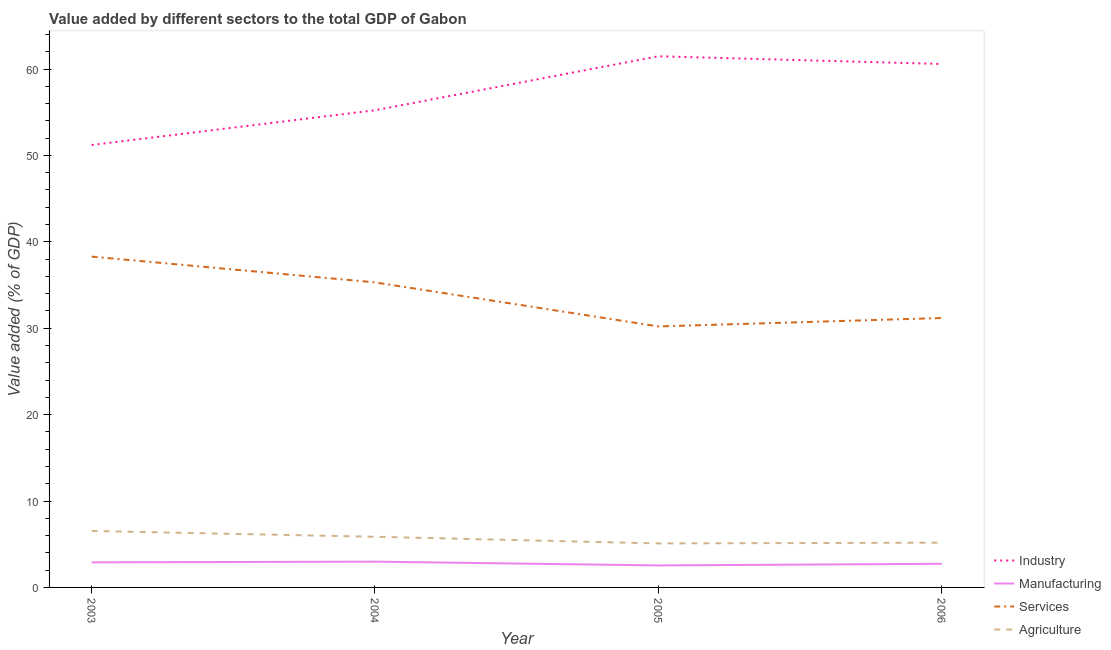How many different coloured lines are there?
Your answer should be very brief. 4. What is the value added by manufacturing sector in 2005?
Your answer should be very brief. 2.55. Across all years, what is the maximum value added by manufacturing sector?
Provide a short and direct response. 2.98. Across all years, what is the minimum value added by manufacturing sector?
Offer a very short reply. 2.55. In which year was the value added by services sector minimum?
Offer a terse response. 2005. What is the total value added by services sector in the graph?
Your answer should be compact. 134.99. What is the difference between the value added by agricultural sector in 2003 and that in 2004?
Offer a terse response. 0.67. What is the difference between the value added by industrial sector in 2004 and the value added by agricultural sector in 2005?
Your answer should be very brief. 50.13. What is the average value added by industrial sector per year?
Your response must be concise. 57.12. In the year 2004, what is the difference between the value added by services sector and value added by industrial sector?
Your answer should be compact. -19.92. In how many years, is the value added by agricultural sector greater than 2 %?
Keep it short and to the point. 4. What is the ratio of the value added by agricultural sector in 2003 to that in 2006?
Your answer should be very brief. 1.26. What is the difference between the highest and the second highest value added by agricultural sector?
Your answer should be compact. 0.67. What is the difference between the highest and the lowest value added by agricultural sector?
Provide a short and direct response. 1.44. Is the sum of the value added by agricultural sector in 2004 and 2005 greater than the maximum value added by industrial sector across all years?
Keep it short and to the point. No. Is it the case that in every year, the sum of the value added by industrial sector and value added by agricultural sector is greater than the sum of value added by manufacturing sector and value added by services sector?
Offer a very short reply. Yes. Does the value added by services sector monotonically increase over the years?
Provide a succinct answer. No. How many lines are there?
Ensure brevity in your answer.  4. Does the graph contain any zero values?
Your answer should be compact. No. Does the graph contain grids?
Your response must be concise. No. Where does the legend appear in the graph?
Keep it short and to the point. Bottom right. How are the legend labels stacked?
Provide a short and direct response. Vertical. What is the title of the graph?
Keep it short and to the point. Value added by different sectors to the total GDP of Gabon. Does "Secondary general education" appear as one of the legend labels in the graph?
Offer a terse response. No. What is the label or title of the X-axis?
Ensure brevity in your answer.  Year. What is the label or title of the Y-axis?
Your response must be concise. Value added (% of GDP). What is the Value added (% of GDP) in Industry in 2003?
Provide a short and direct response. 51.21. What is the Value added (% of GDP) in Manufacturing in 2003?
Provide a short and direct response. 2.9. What is the Value added (% of GDP) of Services in 2003?
Offer a very short reply. 38.29. What is the Value added (% of GDP) of Agriculture in 2003?
Keep it short and to the point. 6.54. What is the Value added (% of GDP) in Industry in 2004?
Provide a short and direct response. 55.23. What is the Value added (% of GDP) of Manufacturing in 2004?
Offer a terse response. 2.98. What is the Value added (% of GDP) in Services in 2004?
Give a very brief answer. 35.3. What is the Value added (% of GDP) of Agriculture in 2004?
Provide a short and direct response. 5.86. What is the Value added (% of GDP) in Industry in 2005?
Offer a very short reply. 61.47. What is the Value added (% of GDP) in Manufacturing in 2005?
Ensure brevity in your answer.  2.55. What is the Value added (% of GDP) of Services in 2005?
Your answer should be very brief. 30.21. What is the Value added (% of GDP) of Agriculture in 2005?
Keep it short and to the point. 5.09. What is the Value added (% of GDP) in Industry in 2006?
Offer a terse response. 60.58. What is the Value added (% of GDP) in Manufacturing in 2006?
Offer a very short reply. 2.74. What is the Value added (% of GDP) of Services in 2006?
Your answer should be compact. 31.18. What is the Value added (% of GDP) in Agriculture in 2006?
Make the answer very short. 5.18. Across all years, what is the maximum Value added (% of GDP) of Industry?
Your answer should be very brief. 61.47. Across all years, what is the maximum Value added (% of GDP) of Manufacturing?
Provide a succinct answer. 2.98. Across all years, what is the maximum Value added (% of GDP) in Services?
Provide a short and direct response. 38.29. Across all years, what is the maximum Value added (% of GDP) in Agriculture?
Make the answer very short. 6.54. Across all years, what is the minimum Value added (% of GDP) in Industry?
Offer a terse response. 51.21. Across all years, what is the minimum Value added (% of GDP) of Manufacturing?
Your answer should be compact. 2.55. Across all years, what is the minimum Value added (% of GDP) of Services?
Keep it short and to the point. 30.21. Across all years, what is the minimum Value added (% of GDP) of Agriculture?
Keep it short and to the point. 5.09. What is the total Value added (% of GDP) of Industry in the graph?
Keep it short and to the point. 228.49. What is the total Value added (% of GDP) in Manufacturing in the graph?
Offer a terse response. 11.17. What is the total Value added (% of GDP) in Services in the graph?
Offer a very short reply. 134.99. What is the total Value added (% of GDP) in Agriculture in the graph?
Provide a short and direct response. 22.67. What is the difference between the Value added (% of GDP) of Industry in 2003 and that in 2004?
Keep it short and to the point. -4.02. What is the difference between the Value added (% of GDP) of Manufacturing in 2003 and that in 2004?
Provide a succinct answer. -0.08. What is the difference between the Value added (% of GDP) of Services in 2003 and that in 2004?
Your answer should be very brief. 2.99. What is the difference between the Value added (% of GDP) of Agriculture in 2003 and that in 2004?
Your answer should be compact. 0.67. What is the difference between the Value added (% of GDP) in Industry in 2003 and that in 2005?
Ensure brevity in your answer.  -10.27. What is the difference between the Value added (% of GDP) in Manufacturing in 2003 and that in 2005?
Your answer should be very brief. 0.36. What is the difference between the Value added (% of GDP) of Services in 2003 and that in 2005?
Your answer should be compact. 8.08. What is the difference between the Value added (% of GDP) in Agriculture in 2003 and that in 2005?
Provide a short and direct response. 1.44. What is the difference between the Value added (% of GDP) of Industry in 2003 and that in 2006?
Provide a succinct answer. -9.37. What is the difference between the Value added (% of GDP) in Manufacturing in 2003 and that in 2006?
Keep it short and to the point. 0.17. What is the difference between the Value added (% of GDP) in Services in 2003 and that in 2006?
Give a very brief answer. 7.11. What is the difference between the Value added (% of GDP) in Agriculture in 2003 and that in 2006?
Ensure brevity in your answer.  1.36. What is the difference between the Value added (% of GDP) in Industry in 2004 and that in 2005?
Your response must be concise. -6.25. What is the difference between the Value added (% of GDP) in Manufacturing in 2004 and that in 2005?
Keep it short and to the point. 0.44. What is the difference between the Value added (% of GDP) in Services in 2004 and that in 2005?
Ensure brevity in your answer.  5.1. What is the difference between the Value added (% of GDP) of Agriculture in 2004 and that in 2005?
Give a very brief answer. 0.77. What is the difference between the Value added (% of GDP) in Industry in 2004 and that in 2006?
Your answer should be compact. -5.36. What is the difference between the Value added (% of GDP) of Manufacturing in 2004 and that in 2006?
Ensure brevity in your answer.  0.25. What is the difference between the Value added (% of GDP) in Services in 2004 and that in 2006?
Provide a succinct answer. 4.12. What is the difference between the Value added (% of GDP) of Agriculture in 2004 and that in 2006?
Your response must be concise. 0.68. What is the difference between the Value added (% of GDP) in Industry in 2005 and that in 2006?
Your answer should be very brief. 0.89. What is the difference between the Value added (% of GDP) in Manufacturing in 2005 and that in 2006?
Keep it short and to the point. -0.19. What is the difference between the Value added (% of GDP) in Services in 2005 and that in 2006?
Give a very brief answer. -0.97. What is the difference between the Value added (% of GDP) in Agriculture in 2005 and that in 2006?
Offer a terse response. -0.08. What is the difference between the Value added (% of GDP) of Industry in 2003 and the Value added (% of GDP) of Manufacturing in 2004?
Your answer should be very brief. 48.22. What is the difference between the Value added (% of GDP) of Industry in 2003 and the Value added (% of GDP) of Services in 2004?
Provide a succinct answer. 15.9. What is the difference between the Value added (% of GDP) of Industry in 2003 and the Value added (% of GDP) of Agriculture in 2004?
Your response must be concise. 45.34. What is the difference between the Value added (% of GDP) of Manufacturing in 2003 and the Value added (% of GDP) of Services in 2004?
Provide a short and direct response. -32.4. What is the difference between the Value added (% of GDP) of Manufacturing in 2003 and the Value added (% of GDP) of Agriculture in 2004?
Offer a terse response. -2.96. What is the difference between the Value added (% of GDP) of Services in 2003 and the Value added (% of GDP) of Agriculture in 2004?
Ensure brevity in your answer.  32.43. What is the difference between the Value added (% of GDP) of Industry in 2003 and the Value added (% of GDP) of Manufacturing in 2005?
Offer a terse response. 48.66. What is the difference between the Value added (% of GDP) of Industry in 2003 and the Value added (% of GDP) of Services in 2005?
Your response must be concise. 21. What is the difference between the Value added (% of GDP) in Industry in 2003 and the Value added (% of GDP) in Agriculture in 2005?
Give a very brief answer. 46.11. What is the difference between the Value added (% of GDP) of Manufacturing in 2003 and the Value added (% of GDP) of Services in 2005?
Your answer should be very brief. -27.3. What is the difference between the Value added (% of GDP) of Manufacturing in 2003 and the Value added (% of GDP) of Agriculture in 2005?
Offer a very short reply. -2.19. What is the difference between the Value added (% of GDP) of Services in 2003 and the Value added (% of GDP) of Agriculture in 2005?
Your response must be concise. 33.2. What is the difference between the Value added (% of GDP) in Industry in 2003 and the Value added (% of GDP) in Manufacturing in 2006?
Provide a short and direct response. 48.47. What is the difference between the Value added (% of GDP) in Industry in 2003 and the Value added (% of GDP) in Services in 2006?
Give a very brief answer. 20.03. What is the difference between the Value added (% of GDP) of Industry in 2003 and the Value added (% of GDP) of Agriculture in 2006?
Offer a very short reply. 46.03. What is the difference between the Value added (% of GDP) in Manufacturing in 2003 and the Value added (% of GDP) in Services in 2006?
Provide a short and direct response. -28.28. What is the difference between the Value added (% of GDP) of Manufacturing in 2003 and the Value added (% of GDP) of Agriculture in 2006?
Your answer should be compact. -2.28. What is the difference between the Value added (% of GDP) of Services in 2003 and the Value added (% of GDP) of Agriculture in 2006?
Your response must be concise. 33.11. What is the difference between the Value added (% of GDP) of Industry in 2004 and the Value added (% of GDP) of Manufacturing in 2005?
Keep it short and to the point. 52.68. What is the difference between the Value added (% of GDP) of Industry in 2004 and the Value added (% of GDP) of Services in 2005?
Offer a very short reply. 25.02. What is the difference between the Value added (% of GDP) in Industry in 2004 and the Value added (% of GDP) in Agriculture in 2005?
Provide a succinct answer. 50.13. What is the difference between the Value added (% of GDP) in Manufacturing in 2004 and the Value added (% of GDP) in Services in 2005?
Keep it short and to the point. -27.23. What is the difference between the Value added (% of GDP) in Manufacturing in 2004 and the Value added (% of GDP) in Agriculture in 2005?
Make the answer very short. -2.11. What is the difference between the Value added (% of GDP) in Services in 2004 and the Value added (% of GDP) in Agriculture in 2005?
Your answer should be compact. 30.21. What is the difference between the Value added (% of GDP) of Industry in 2004 and the Value added (% of GDP) of Manufacturing in 2006?
Your response must be concise. 52.49. What is the difference between the Value added (% of GDP) of Industry in 2004 and the Value added (% of GDP) of Services in 2006?
Give a very brief answer. 24.04. What is the difference between the Value added (% of GDP) in Industry in 2004 and the Value added (% of GDP) in Agriculture in 2006?
Your response must be concise. 50.05. What is the difference between the Value added (% of GDP) of Manufacturing in 2004 and the Value added (% of GDP) of Services in 2006?
Ensure brevity in your answer.  -28.2. What is the difference between the Value added (% of GDP) of Manufacturing in 2004 and the Value added (% of GDP) of Agriculture in 2006?
Give a very brief answer. -2.2. What is the difference between the Value added (% of GDP) of Services in 2004 and the Value added (% of GDP) of Agriculture in 2006?
Provide a succinct answer. 30.13. What is the difference between the Value added (% of GDP) of Industry in 2005 and the Value added (% of GDP) of Manufacturing in 2006?
Offer a very short reply. 58.74. What is the difference between the Value added (% of GDP) of Industry in 2005 and the Value added (% of GDP) of Services in 2006?
Ensure brevity in your answer.  30.29. What is the difference between the Value added (% of GDP) in Industry in 2005 and the Value added (% of GDP) in Agriculture in 2006?
Provide a short and direct response. 56.29. What is the difference between the Value added (% of GDP) of Manufacturing in 2005 and the Value added (% of GDP) of Services in 2006?
Provide a succinct answer. -28.63. What is the difference between the Value added (% of GDP) of Manufacturing in 2005 and the Value added (% of GDP) of Agriculture in 2006?
Provide a short and direct response. -2.63. What is the difference between the Value added (% of GDP) in Services in 2005 and the Value added (% of GDP) in Agriculture in 2006?
Make the answer very short. 25.03. What is the average Value added (% of GDP) in Industry per year?
Keep it short and to the point. 57.12. What is the average Value added (% of GDP) of Manufacturing per year?
Ensure brevity in your answer.  2.79. What is the average Value added (% of GDP) in Services per year?
Provide a short and direct response. 33.75. What is the average Value added (% of GDP) of Agriculture per year?
Give a very brief answer. 5.67. In the year 2003, what is the difference between the Value added (% of GDP) of Industry and Value added (% of GDP) of Manufacturing?
Keep it short and to the point. 48.3. In the year 2003, what is the difference between the Value added (% of GDP) of Industry and Value added (% of GDP) of Services?
Your response must be concise. 12.92. In the year 2003, what is the difference between the Value added (% of GDP) in Industry and Value added (% of GDP) in Agriculture?
Provide a short and direct response. 44.67. In the year 2003, what is the difference between the Value added (% of GDP) in Manufacturing and Value added (% of GDP) in Services?
Give a very brief answer. -35.39. In the year 2003, what is the difference between the Value added (% of GDP) of Manufacturing and Value added (% of GDP) of Agriculture?
Keep it short and to the point. -3.63. In the year 2003, what is the difference between the Value added (% of GDP) in Services and Value added (% of GDP) in Agriculture?
Ensure brevity in your answer.  31.75. In the year 2004, what is the difference between the Value added (% of GDP) of Industry and Value added (% of GDP) of Manufacturing?
Your answer should be compact. 52.24. In the year 2004, what is the difference between the Value added (% of GDP) of Industry and Value added (% of GDP) of Services?
Your answer should be very brief. 19.92. In the year 2004, what is the difference between the Value added (% of GDP) in Industry and Value added (% of GDP) in Agriculture?
Keep it short and to the point. 49.36. In the year 2004, what is the difference between the Value added (% of GDP) in Manufacturing and Value added (% of GDP) in Services?
Provide a succinct answer. -32.32. In the year 2004, what is the difference between the Value added (% of GDP) of Manufacturing and Value added (% of GDP) of Agriculture?
Your answer should be compact. -2.88. In the year 2004, what is the difference between the Value added (% of GDP) of Services and Value added (% of GDP) of Agriculture?
Your answer should be compact. 29.44. In the year 2005, what is the difference between the Value added (% of GDP) of Industry and Value added (% of GDP) of Manufacturing?
Provide a short and direct response. 58.93. In the year 2005, what is the difference between the Value added (% of GDP) of Industry and Value added (% of GDP) of Services?
Your answer should be very brief. 31.27. In the year 2005, what is the difference between the Value added (% of GDP) in Industry and Value added (% of GDP) in Agriculture?
Offer a very short reply. 56.38. In the year 2005, what is the difference between the Value added (% of GDP) in Manufacturing and Value added (% of GDP) in Services?
Your answer should be compact. -27.66. In the year 2005, what is the difference between the Value added (% of GDP) of Manufacturing and Value added (% of GDP) of Agriculture?
Provide a short and direct response. -2.55. In the year 2005, what is the difference between the Value added (% of GDP) in Services and Value added (% of GDP) in Agriculture?
Ensure brevity in your answer.  25.11. In the year 2006, what is the difference between the Value added (% of GDP) of Industry and Value added (% of GDP) of Manufacturing?
Provide a short and direct response. 57.85. In the year 2006, what is the difference between the Value added (% of GDP) in Industry and Value added (% of GDP) in Services?
Offer a very short reply. 29.4. In the year 2006, what is the difference between the Value added (% of GDP) in Industry and Value added (% of GDP) in Agriculture?
Provide a short and direct response. 55.4. In the year 2006, what is the difference between the Value added (% of GDP) in Manufacturing and Value added (% of GDP) in Services?
Your answer should be compact. -28.45. In the year 2006, what is the difference between the Value added (% of GDP) in Manufacturing and Value added (% of GDP) in Agriculture?
Provide a succinct answer. -2.44. In the year 2006, what is the difference between the Value added (% of GDP) of Services and Value added (% of GDP) of Agriculture?
Your answer should be very brief. 26. What is the ratio of the Value added (% of GDP) of Industry in 2003 to that in 2004?
Provide a short and direct response. 0.93. What is the ratio of the Value added (% of GDP) in Manufacturing in 2003 to that in 2004?
Your answer should be very brief. 0.97. What is the ratio of the Value added (% of GDP) of Services in 2003 to that in 2004?
Offer a terse response. 1.08. What is the ratio of the Value added (% of GDP) of Agriculture in 2003 to that in 2004?
Provide a succinct answer. 1.11. What is the ratio of the Value added (% of GDP) in Industry in 2003 to that in 2005?
Your response must be concise. 0.83. What is the ratio of the Value added (% of GDP) in Manufacturing in 2003 to that in 2005?
Provide a succinct answer. 1.14. What is the ratio of the Value added (% of GDP) in Services in 2003 to that in 2005?
Ensure brevity in your answer.  1.27. What is the ratio of the Value added (% of GDP) of Agriculture in 2003 to that in 2005?
Your answer should be very brief. 1.28. What is the ratio of the Value added (% of GDP) of Industry in 2003 to that in 2006?
Provide a short and direct response. 0.85. What is the ratio of the Value added (% of GDP) of Manufacturing in 2003 to that in 2006?
Provide a short and direct response. 1.06. What is the ratio of the Value added (% of GDP) of Services in 2003 to that in 2006?
Provide a short and direct response. 1.23. What is the ratio of the Value added (% of GDP) in Agriculture in 2003 to that in 2006?
Keep it short and to the point. 1.26. What is the ratio of the Value added (% of GDP) in Industry in 2004 to that in 2005?
Make the answer very short. 0.9. What is the ratio of the Value added (% of GDP) in Manufacturing in 2004 to that in 2005?
Your answer should be very brief. 1.17. What is the ratio of the Value added (% of GDP) of Services in 2004 to that in 2005?
Keep it short and to the point. 1.17. What is the ratio of the Value added (% of GDP) in Agriculture in 2004 to that in 2005?
Keep it short and to the point. 1.15. What is the ratio of the Value added (% of GDP) of Industry in 2004 to that in 2006?
Your response must be concise. 0.91. What is the ratio of the Value added (% of GDP) in Manufacturing in 2004 to that in 2006?
Ensure brevity in your answer.  1.09. What is the ratio of the Value added (% of GDP) of Services in 2004 to that in 2006?
Offer a terse response. 1.13. What is the ratio of the Value added (% of GDP) in Agriculture in 2004 to that in 2006?
Your answer should be very brief. 1.13. What is the ratio of the Value added (% of GDP) of Industry in 2005 to that in 2006?
Ensure brevity in your answer.  1.01. What is the ratio of the Value added (% of GDP) in Services in 2005 to that in 2006?
Your answer should be compact. 0.97. What is the ratio of the Value added (% of GDP) of Agriculture in 2005 to that in 2006?
Your answer should be very brief. 0.98. What is the difference between the highest and the second highest Value added (% of GDP) in Industry?
Provide a succinct answer. 0.89. What is the difference between the highest and the second highest Value added (% of GDP) of Manufacturing?
Ensure brevity in your answer.  0.08. What is the difference between the highest and the second highest Value added (% of GDP) in Services?
Offer a very short reply. 2.99. What is the difference between the highest and the second highest Value added (% of GDP) in Agriculture?
Your answer should be very brief. 0.67. What is the difference between the highest and the lowest Value added (% of GDP) in Industry?
Offer a terse response. 10.27. What is the difference between the highest and the lowest Value added (% of GDP) of Manufacturing?
Provide a short and direct response. 0.44. What is the difference between the highest and the lowest Value added (% of GDP) of Services?
Provide a short and direct response. 8.08. What is the difference between the highest and the lowest Value added (% of GDP) in Agriculture?
Your answer should be very brief. 1.44. 